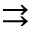<formula> <loc_0><loc_0><loc_500><loc_500>\right r i g h t a r r o w s</formula> 